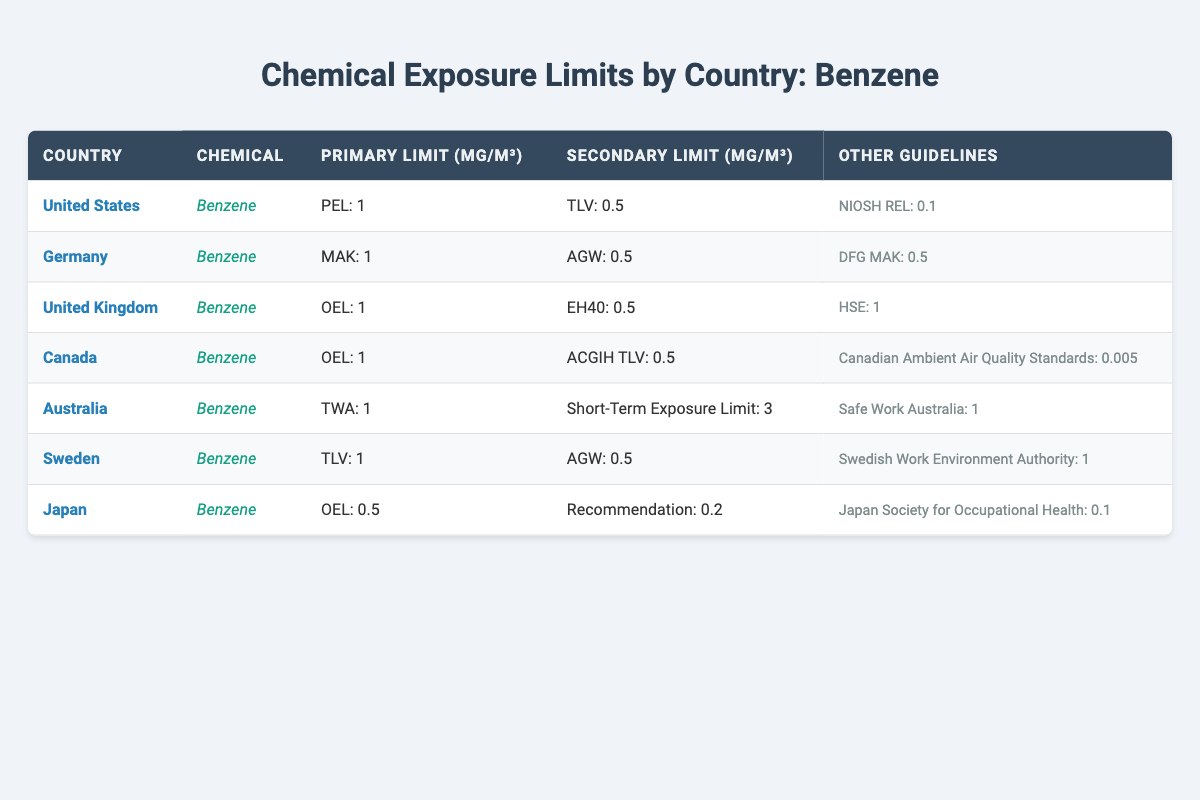What is the primary limit for Benzene in the United States? The table indicates that the primary exposure limit for Benzene in the United States is set at 1 mg/m³ as per the PEL (Permissible Exposure Limit).
Answer: 1 mg/m³ Which country has the lowest secondary limit for Benzene? By examining the secondary limits listed in the table, Japan has the lowest secondary limit for Benzene at 0.2 mg/m³.
Answer: Japan What is the average primary limit of Benzene across the listed countries? The primary limits from the countries are: 1 (US) + 1 (Germany) + 1 (UK) + 1 (Canada) + 1 (Australia) + 1 (Sweden) + 0.5 (Japan) = 6.5 mg/m³ total. There are 7 countries, so the average is 6.5/7 ≈ 0.93 mg/m³.
Answer: Approximately 0.93 mg/m³ Is the short-term exposure limit for Benzene in Australia greater than 2 mg/m³? According to the table, the short-term exposure limit in Australia for Benzene is 3 mg/m³, which is greater than 2 mg/m³.
Answer: Yes Which countries have a primary limit of 1 mg/m³ for Benzene? The countries with a primary limit of 1 mg/m³ for Benzene are the United States, Germany, United Kingdom, Canada, Australia, and Sweden. There are 6 countries in total.
Answer: 6 countries (US, Germany, UK, Canada, Australia, Sweden) What is the difference in the secondary limit for Benzene between Canada and Japan? In Canada, the secondary limit for Benzene is 0.5 mg/m³ (ACGIH TLV), and in Japan, it is 0.2 mg/m³ (Recommendation). The difference is 0.5 - 0.2 = 0.3 mg/m³.
Answer: 0.3 mg/m³ Does any country have a primary limit that is higher than 1 mg/m³ for Benzene? Reviewing the table indicates that all countries listed have a primary limit of 1 mg/m³ or lower, thus no country has a primary limit higher than 1 mg/m³.
Answer: No Which country has the strictest guideline for Benzene exposure? The guideline from Canada states 0.005 mg/m³ as the Canadian Ambient Air Quality Standards, which is the strictest among the other listed guidelines for Benzene exposure.
Answer: Canada 